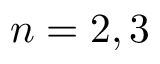Convert formula to latex. <formula><loc_0><loc_0><loc_500><loc_500>n = 2 , 3</formula> 